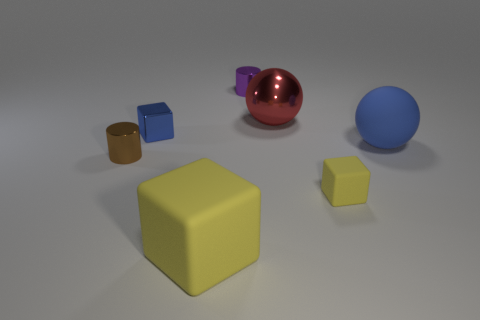Does the blue metal object have the same shape as the yellow rubber thing in front of the small yellow block?
Give a very brief answer. Yes. What size is the shiny thing that is right of the brown cylinder and left of the big yellow object?
Make the answer very short. Small. Are there any tiny brown objects that have the same material as the small blue object?
Provide a succinct answer. Yes. What size is the rubber sphere that is the same color as the small shiny block?
Your answer should be compact. Large. The blue object behind the large ball that is right of the big red thing is made of what material?
Provide a succinct answer. Metal. What number of matte balls are the same color as the big cube?
Provide a short and direct response. 0. What is the size of the cube that is the same material as the brown thing?
Keep it short and to the point. Small. The yellow object to the right of the purple object has what shape?
Your answer should be compact. Cube. The blue matte object that is the same shape as the big red shiny thing is what size?
Ensure brevity in your answer.  Large. There is a cylinder on the right side of the shiny cylinder that is on the left side of the purple thing; how many metal things are behind it?
Provide a succinct answer. 0. 